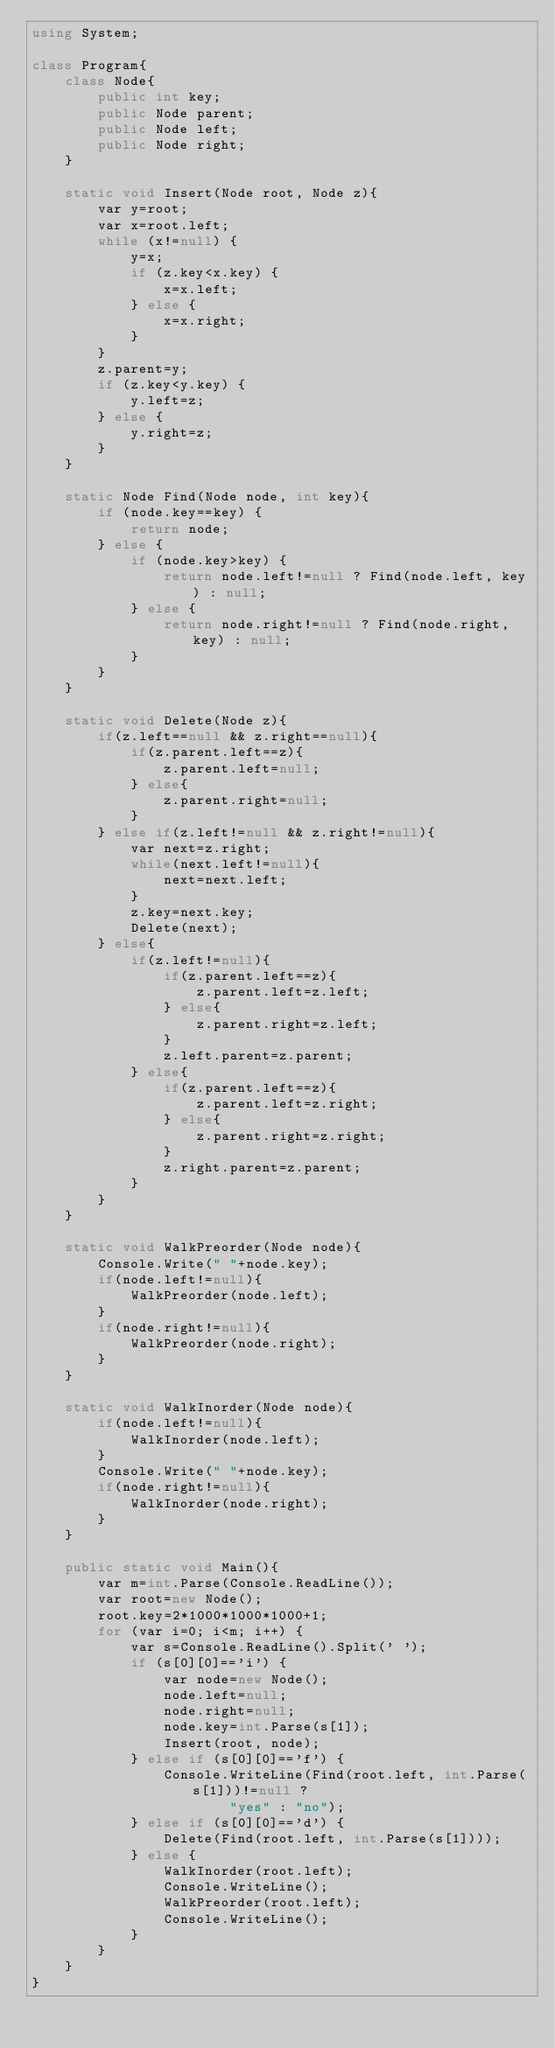<code> <loc_0><loc_0><loc_500><loc_500><_C#_>using System;

class Program{
    class Node{
        public int key;
        public Node parent;
        public Node left;
        public Node right;
    }

    static void Insert(Node root, Node z){
        var y=root;
        var x=root.left;
        while (x!=null) {
            y=x;
            if (z.key<x.key) {
                x=x.left;
            } else {
                x=x.right;
            }
        }
        z.parent=y;
        if (z.key<y.key) {
            y.left=z;
        } else {
            y.right=z;
        }
    }

    static Node Find(Node node, int key){
        if (node.key==key) {
            return node;
        } else {
            if (node.key>key) {
                return node.left!=null ? Find(node.left, key) : null;
            } else {
                return node.right!=null ? Find(node.right, key) : null;
            }
        }
    }

    static void Delete(Node z){
        if(z.left==null && z.right==null){
            if(z.parent.left==z){
                z.parent.left=null;
            } else{
                z.parent.right=null;
            }
        } else if(z.left!=null && z.right!=null){
            var next=z.right;
            while(next.left!=null){
                next=next.left;
            }
            z.key=next.key;
            Delete(next);
        } else{
            if(z.left!=null){
                if(z.parent.left==z){
                    z.parent.left=z.left;
                } else{
                    z.parent.right=z.left;
                }
                z.left.parent=z.parent;
            } else{
                if(z.parent.left==z){
                    z.parent.left=z.right;
                } else{
                    z.parent.right=z.right;
                }
                z.right.parent=z.parent;
            }
        }
    }

    static void WalkPreorder(Node node){
        Console.Write(" "+node.key);
        if(node.left!=null){
            WalkPreorder(node.left);
        }
        if(node.right!=null){
            WalkPreorder(node.right);
        }
    }

    static void WalkInorder(Node node){
        if(node.left!=null){
            WalkInorder(node.left);
        }
        Console.Write(" "+node.key);
        if(node.right!=null){
            WalkInorder(node.right);
        }
    }

    public static void Main(){
        var m=int.Parse(Console.ReadLine());
        var root=new Node();
        root.key=2*1000*1000*1000+1;
        for (var i=0; i<m; i++) {
            var s=Console.ReadLine().Split(' ');
            if (s[0][0]=='i') {
                var node=new Node();
                node.left=null;
                node.right=null;
                node.key=int.Parse(s[1]);
                Insert(root, node);
            } else if (s[0][0]=='f') {
                Console.WriteLine(Find(root.left, int.Parse(s[1]))!=null ?
                        "yes" : "no");
            } else if (s[0][0]=='d') {
                Delete(Find(root.left, int.Parse(s[1])));
            } else {
                WalkInorder(root.left);
                Console.WriteLine();
                WalkPreorder(root.left);
                Console.WriteLine();
            }
        }
    }
}</code> 